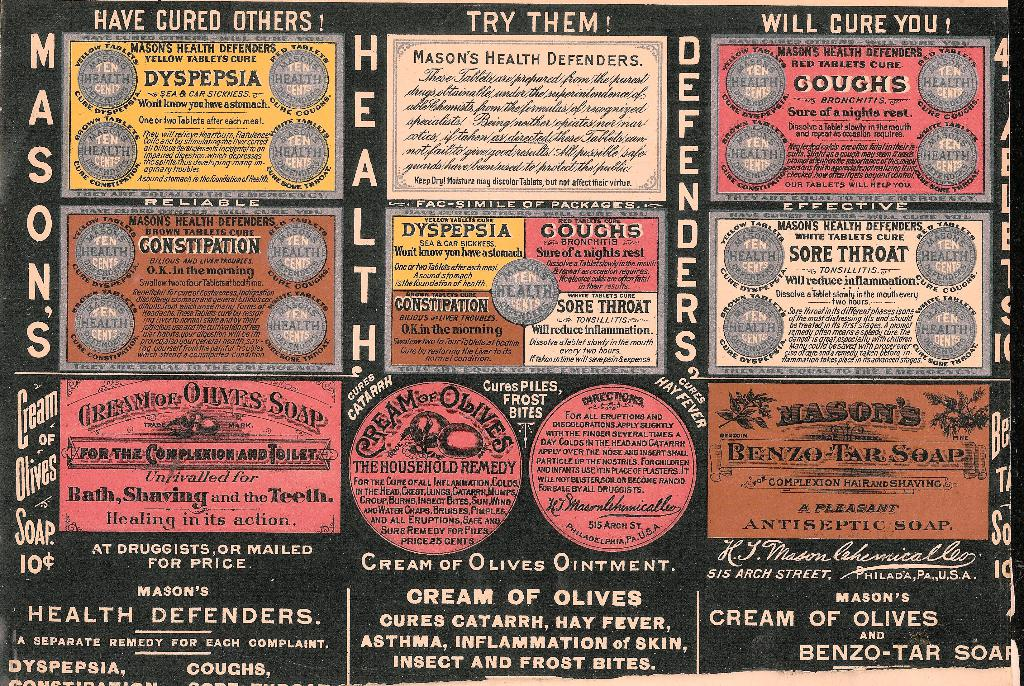Provide a one-sentence caption for the provided image. The image features a vintage advertisement for Mason's Health Defenders, a range of medicinal products claimed to cure ailments such as dyspepsia, coughs, sore throat, constipation, and more, with detailed descriptions and endorsements for each remedy. 